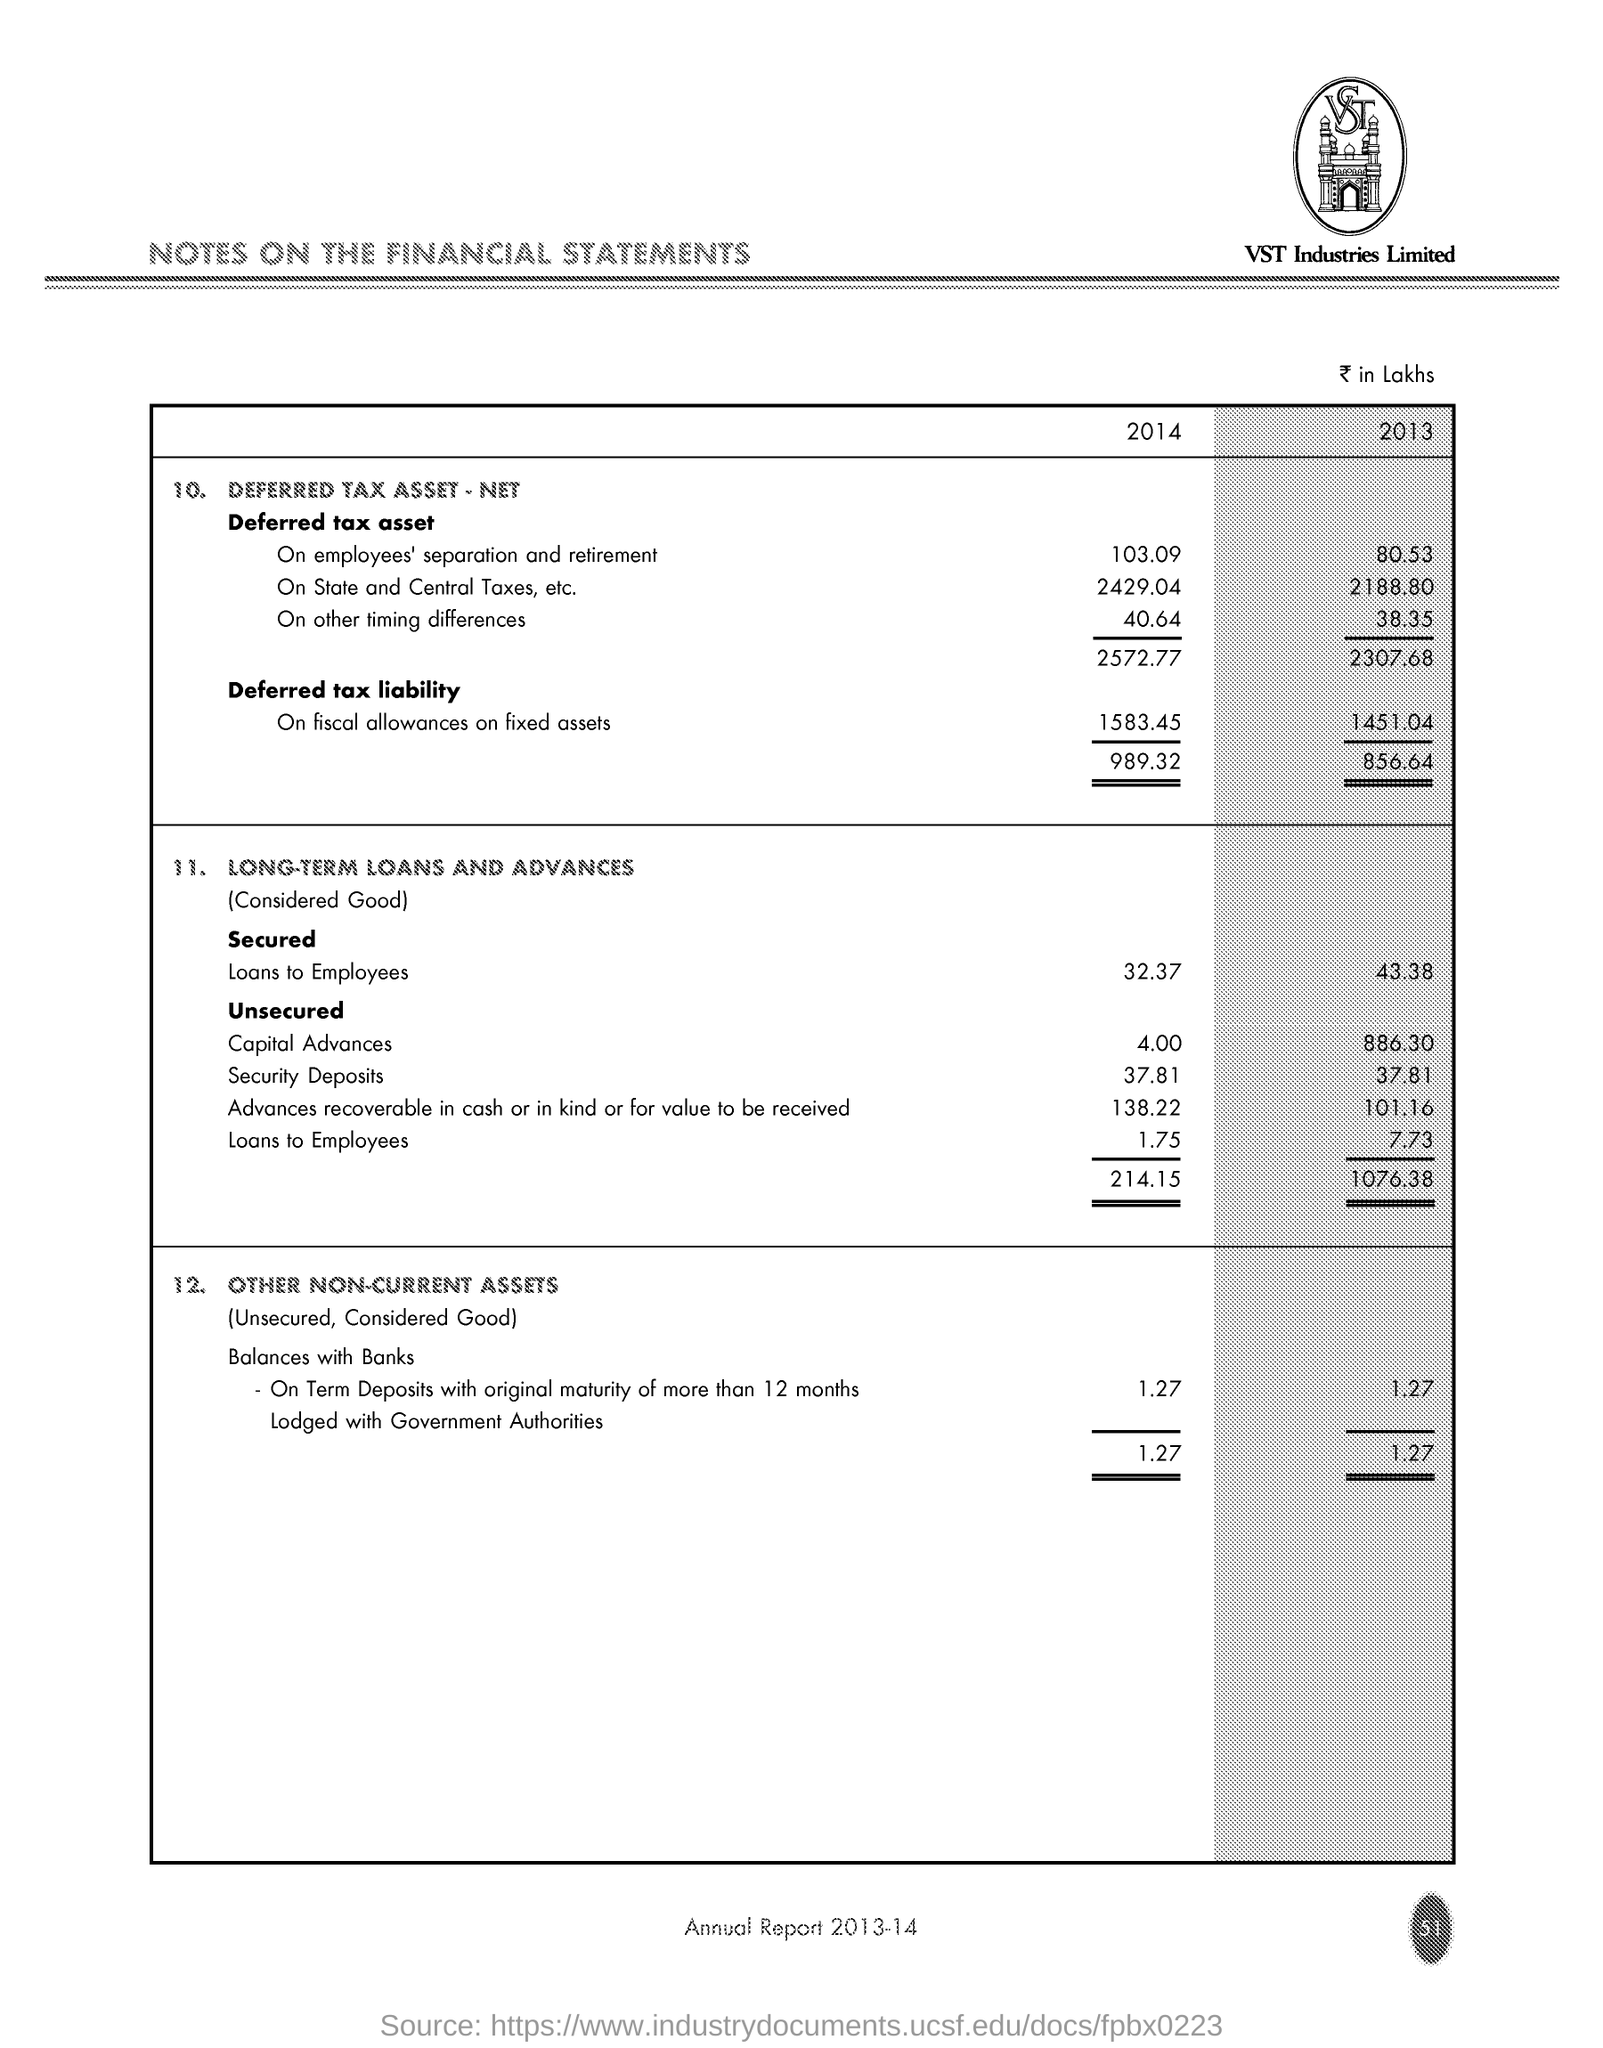Point out several critical features in this image. For the year 2013, the amount of Secured Loans provided to Employees was 43.38 crores, approximately Rs 433.8 million. The company whose name appears at the top of the page is VST Industries Limited. This Annual Report is for the year 2013-2014. 